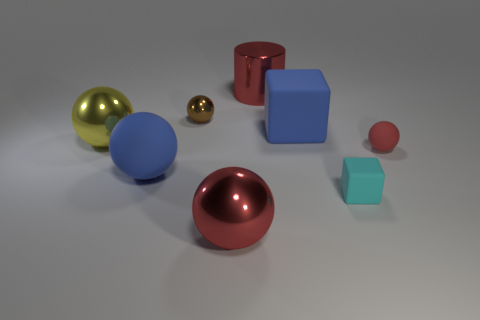What number of red objects are large cylinders or tiny cylinders? In the image, there is one large red cylinder. There are no tiny red cylinders visible, so the total number of red cylinders, regardless of size, is one. 